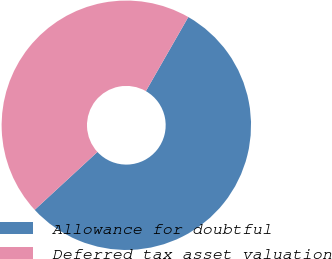Convert chart to OTSL. <chart><loc_0><loc_0><loc_500><loc_500><pie_chart><fcel>Allowance for doubtful<fcel>Deferred tax asset valuation<nl><fcel>54.86%<fcel>45.14%<nl></chart> 